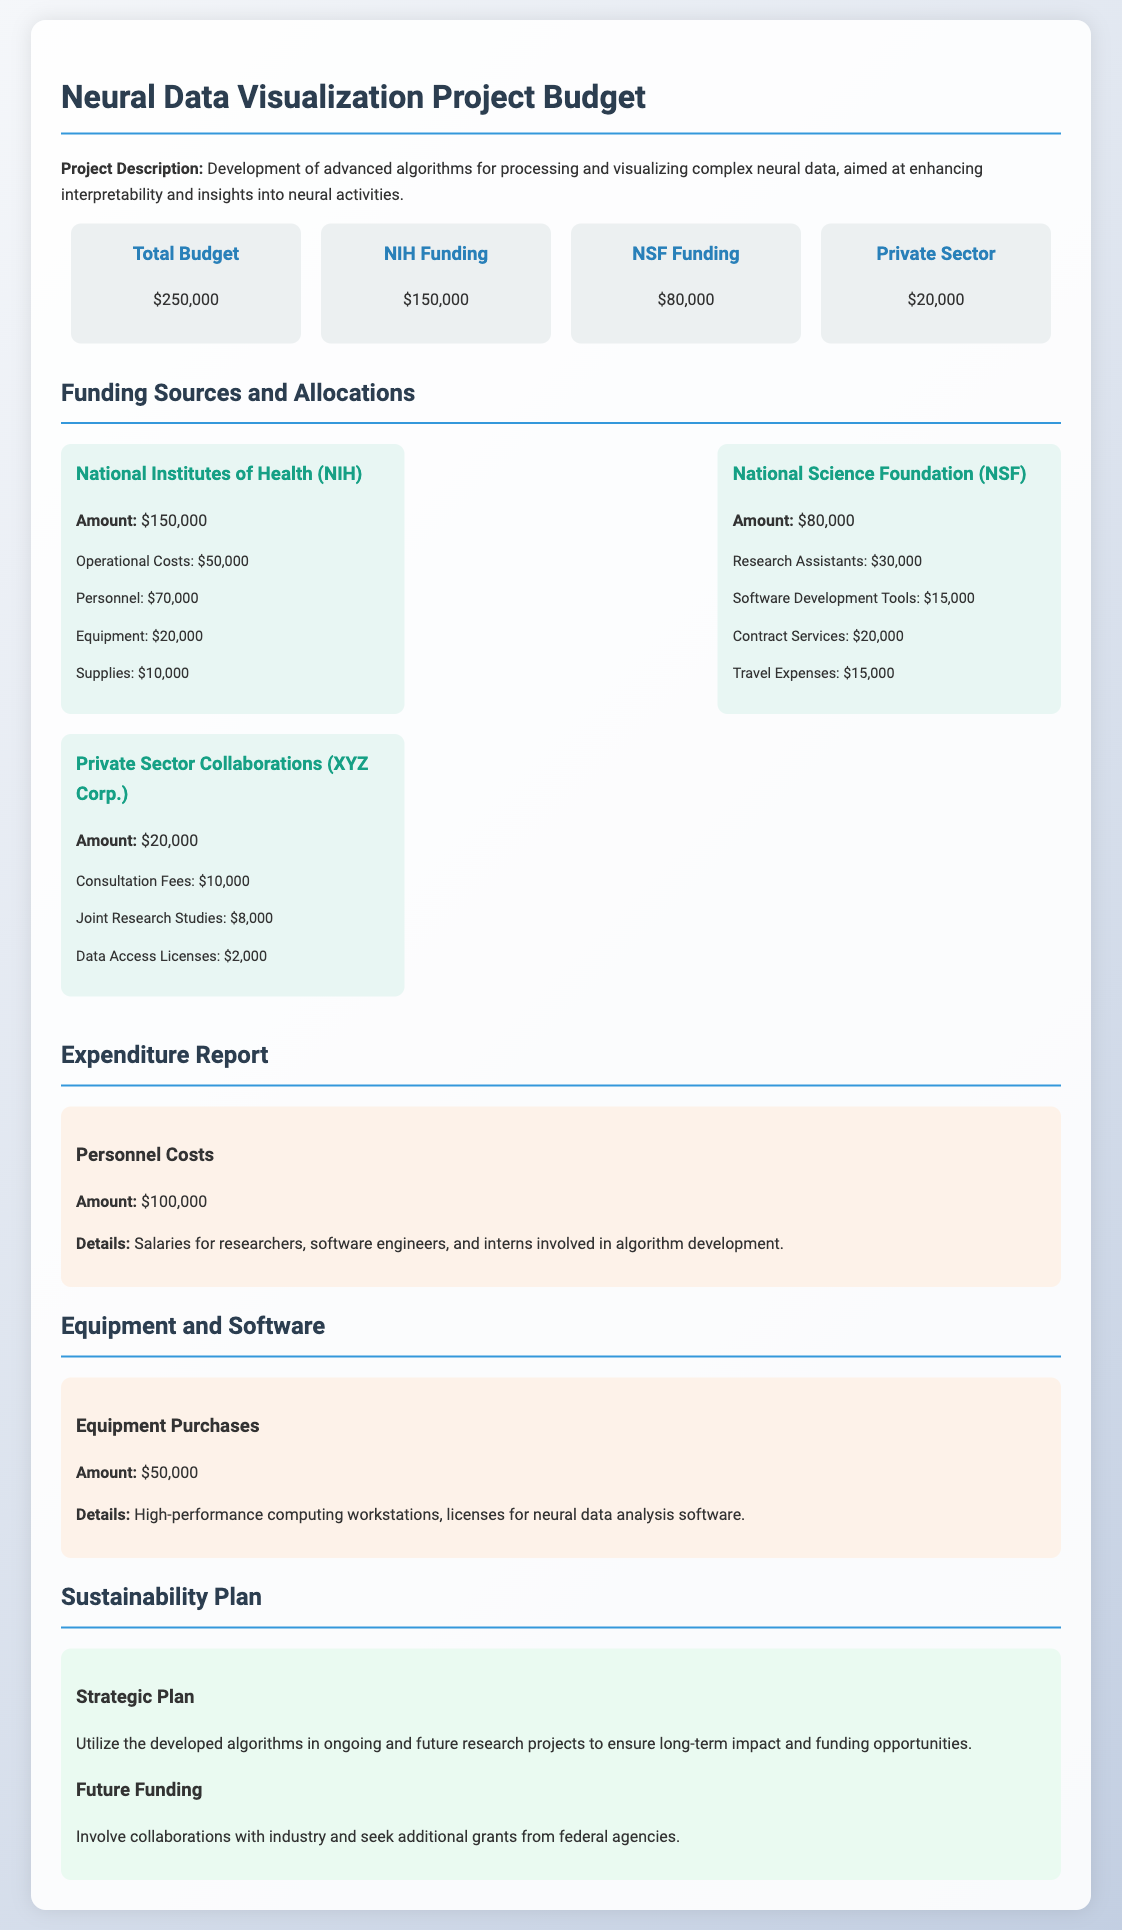what is the total budget? The total budget of the project, as stated in the document, is $250,000.
Answer: $250,000 how much funding comes from NIH? The funding amount from the National Institutes of Health (NIH) is explicitly mentioned in the budget summary.
Answer: $150,000 what is the allocation for personnel costs? Personnel costs are detailed separately in the expenditure section, specifying the total amount allocated.
Answer: $100,000 how much funding is allocated to Research Assistants under NSF? The budget provides a breakdown of the NSF funding, including the specific allocation for Research Assistants.
Answer: $30,000 what is the amount specified for equipment purchases? The amount for equipment purchases is clearly listed in the equipment section of the budget report.
Answer: $50,000 what are the total operational costs funded by NIH? The operational costs, as outlined in the NIH funding allocation, contribute to the overall budget.
Answer: $50,000 which private sector collaboration is mentioned in the document? The budget details the collaboration with a specific company under the private sector funding.
Answer: XYZ Corp what percentage of the total budget is funded by NSF? To find this percentage, the funding amount from NSF is divided by the total budget amount and multiplied by 100.
Answer: 32% how much is allocated for consultation fees under private sector funding? The private sector funding allocation details the amount specifically set aside for consultation fees.
Answer: $10,000 what is the sustainability plan for the project? The document outlines a strategic plan to ensure the project's long-term impact and funding opportunities.
Answer: Utilize developed algorithms in ongoing and future research projects 